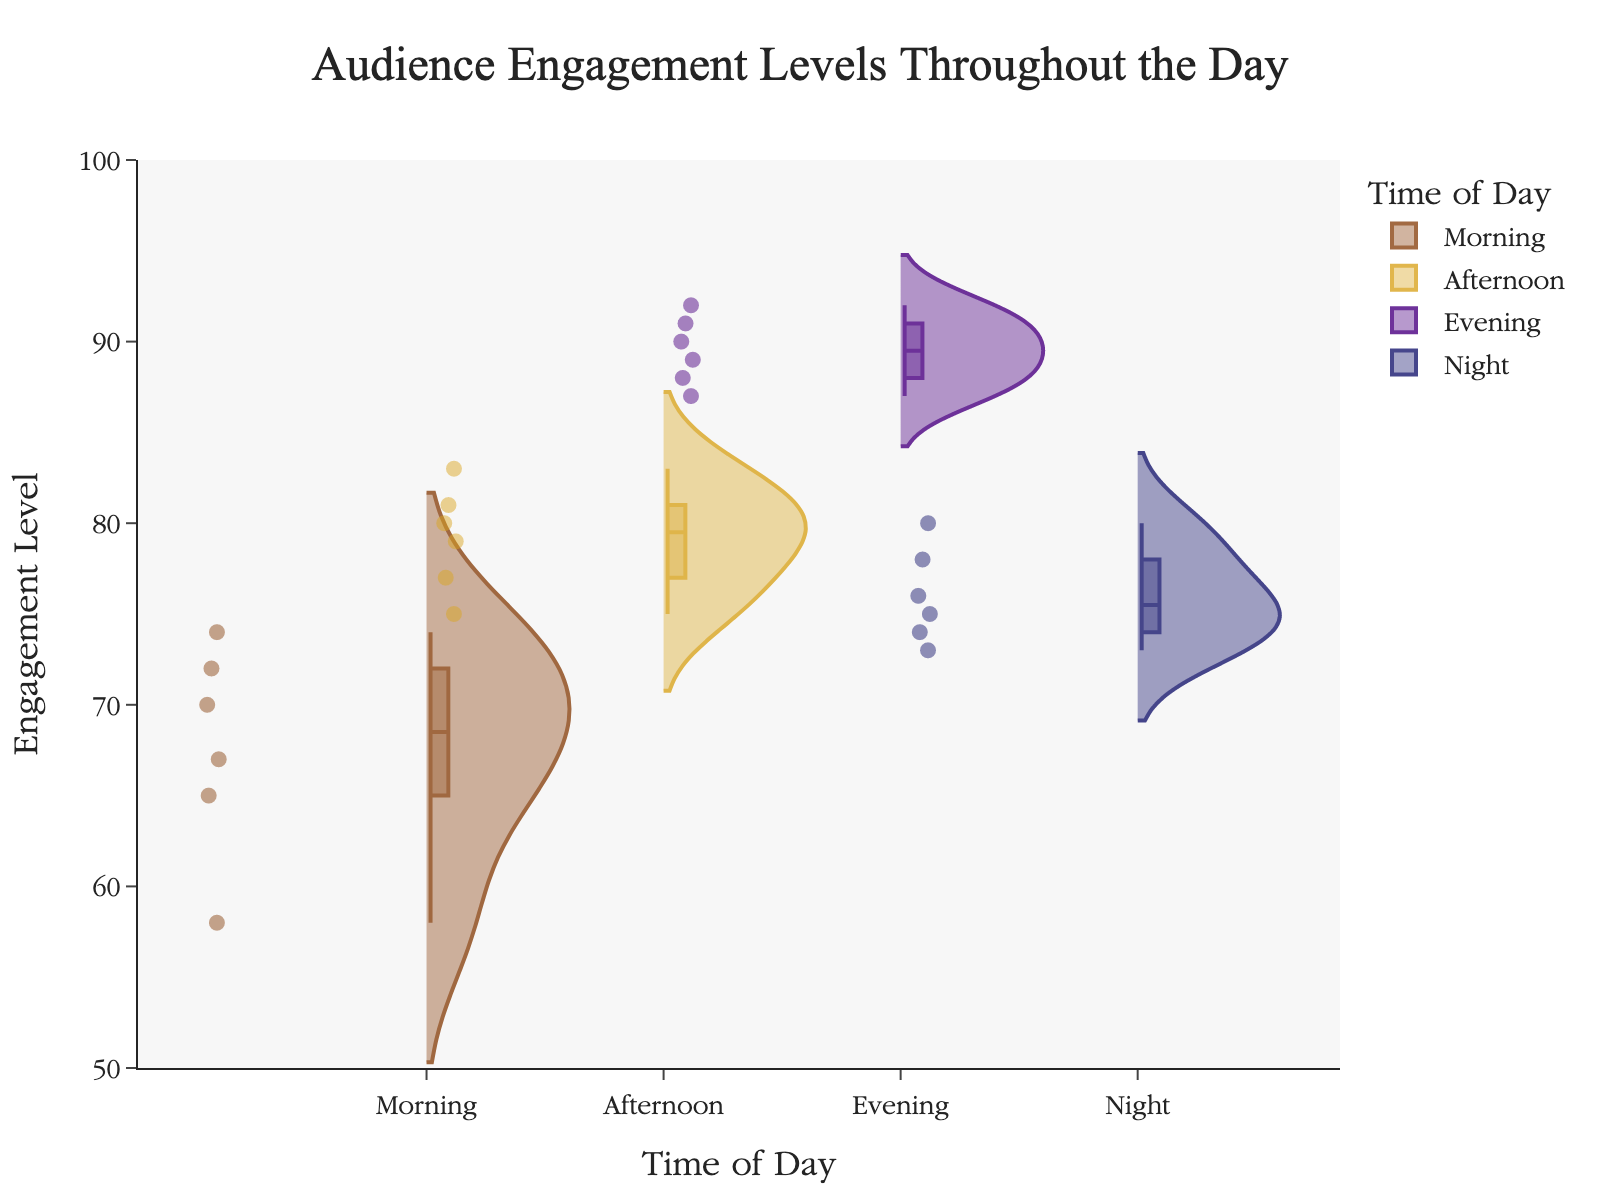What is the title of the violin plot? The title is usually located at the top of the plot and provides a summary of what the plot is about.
Answer: Audience Engagement Levels Throughout the Day Which time of day has the highest median audience engagement? Look for the horizontal line within the box inside the violin plot that marks the median value, and identify which time period has the highest line.
Answer: Evening How many data points are there in the "Evening" category? Count the individual points within the Evening violin plot. There should be 6 data points visible.
Answer: 6 What are the axes labels in the violin plot? The x-axis label and y-axis label provide information on the plotted categories and values respectively.
Answer: Time of Day, Engagement Level What is the range of audience engagement levels represented on the y-axis? Check the y-axis for the minimum and maximum values that outline the range of the plot.
Answer: 50 to 100 Which time of day shows the most variability in audience engagement levels? Variability is indicated by the width and spread of the violin plot. The widest and most spread out plot indicates the most variability.
Answer: Morning What is the interquartile range (IQR) of audience engagement for the "Afternoon" category? The IQR is the range between the first (Q1) and third quartile (Q3) within the box of the violin plot for the Afternoon data. Identify and calculate this range.
Answer: ~75 to ~81 Compare the central tendencies of audience engagement in the "Morning" and "Night" categories. Which one is higher? Look at the median lines within the boxes for both Morning and Night. Determine which median line is higher.
Answer: Morning Which time of day has the lowest minimum audience engagement value? Identify the lowest point in each violin plot, which usually is displayed at the bottom of the plot.
Answer: Morning Does the "Night" category show any outliers in audience engagement levels? Outliers are marked as individual points outside the main bulk of the data in the violin plot. Check if the Night category has any such points.
Answer: No 